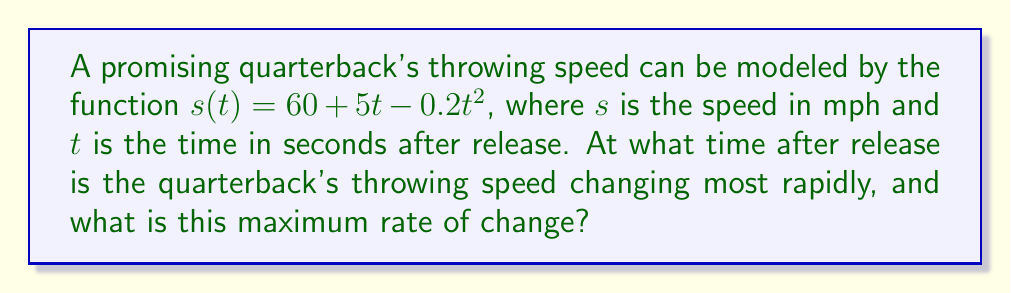Solve this math problem. To solve this problem, we need to follow these steps:

1) The rate of change of speed is given by the derivative of $s(t)$. Let's call this $s'(t)$.

2) To find $s'(t)$, we differentiate $s(t)$:
   $$s'(t) = \frac{d}{dt}(60 + 5t - 0.2t^2) = 5 - 0.4t$$

3) The rate of change is changing most rapidly when $s'(t)$ is at its maximum or minimum. To find this, we need to find where the derivative of $s'(t)$ equals zero.

4) The derivative of $s'(t)$ is $s''(t)$:
   $$s''(t) = \frac{d}{dt}(5 - 0.4t) = -0.4$$

5) Since $s''(t)$ is a constant negative value, $s'(t)$ is always decreasing. This means $s'(t)$ reaches its maximum value at the earliest possible time, which is $t = 0$.

6) To find the maximum rate of change, we evaluate $s'(t)$ at $t = 0$:
   $$s'(0) = 5 - 0.4(0) = 5$$

Therefore, the throwing speed is changing most rapidly at the moment of release $(t = 0)$, and the maximum rate of change is 5 mph/s.
Answer: $t = 0$ seconds, 5 mph/s 